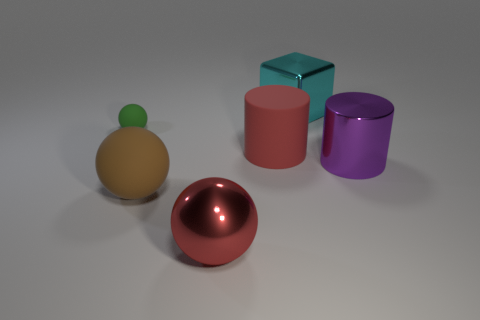Subtract all big red spheres. How many spheres are left? 2 Subtract 2 spheres. How many spheres are left? 1 Add 2 red rubber things. How many objects exist? 8 Subtract all cylinders. How many objects are left? 4 Subtract 1 red spheres. How many objects are left? 5 Subtract all red spheres. Subtract all yellow cubes. How many spheres are left? 2 Subtract all tiny yellow matte cubes. Subtract all cyan things. How many objects are left? 5 Add 6 cyan metal cubes. How many cyan metal cubes are left? 7 Add 5 large brown metal cylinders. How many large brown metal cylinders exist? 5 